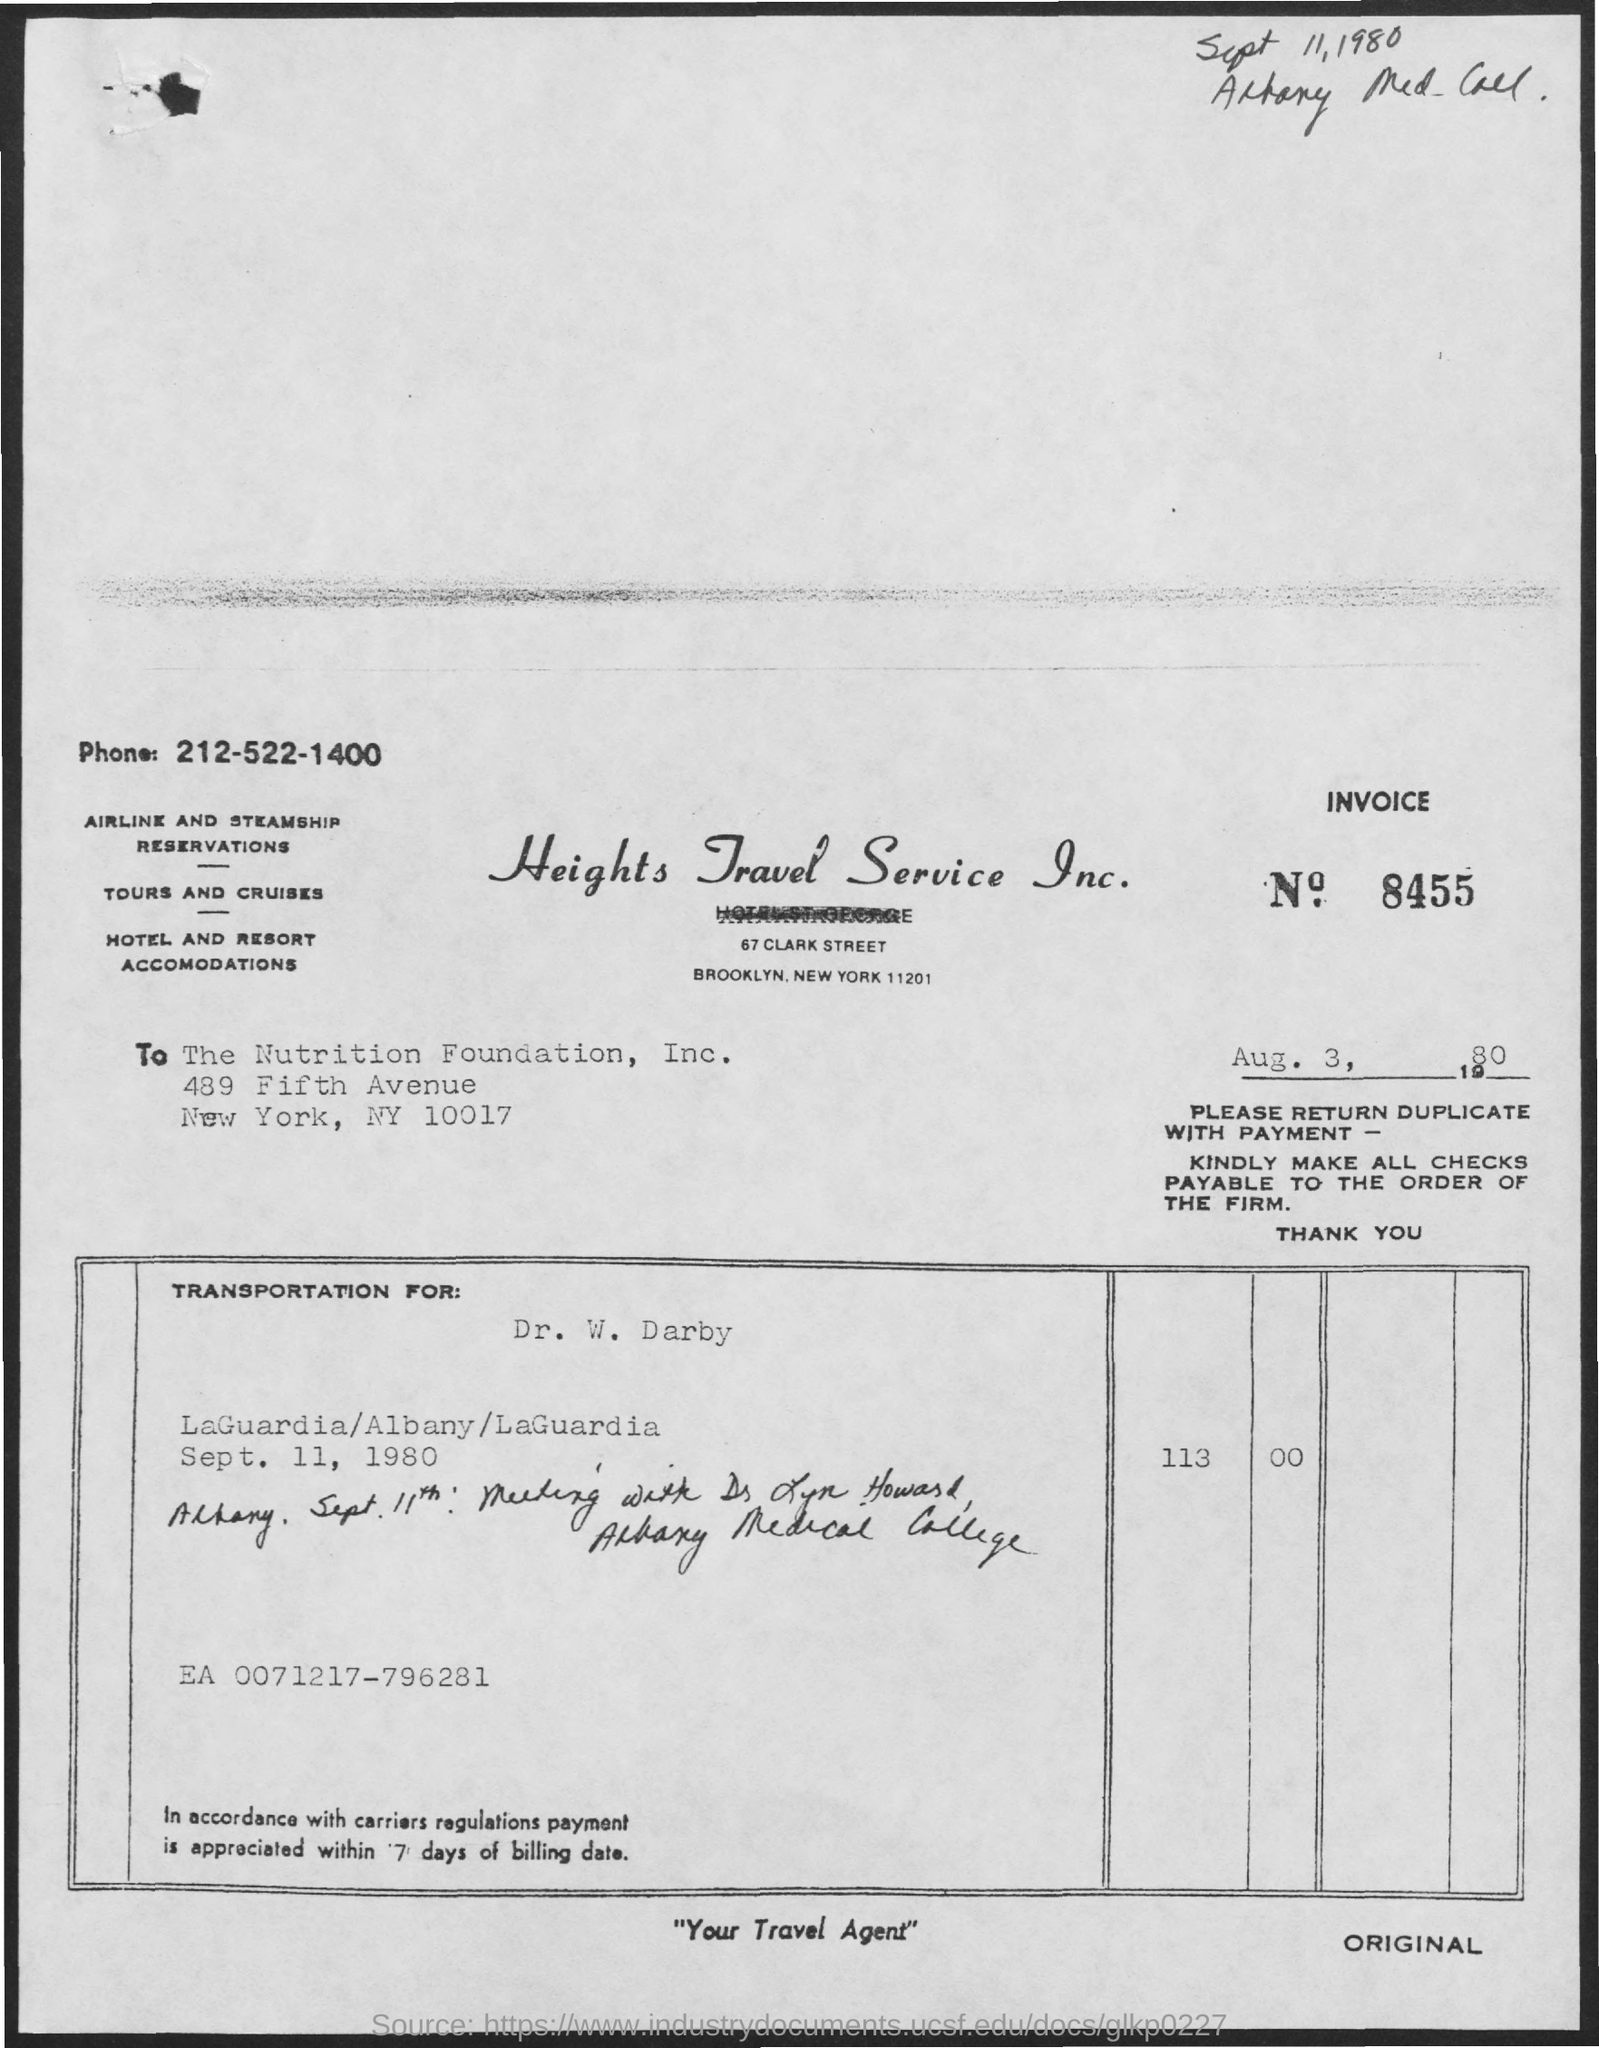What is the Company Name ?
Offer a very short reply. Heights Travel Service Inc. What is the Invoice Number ?
Ensure brevity in your answer.  8455. 